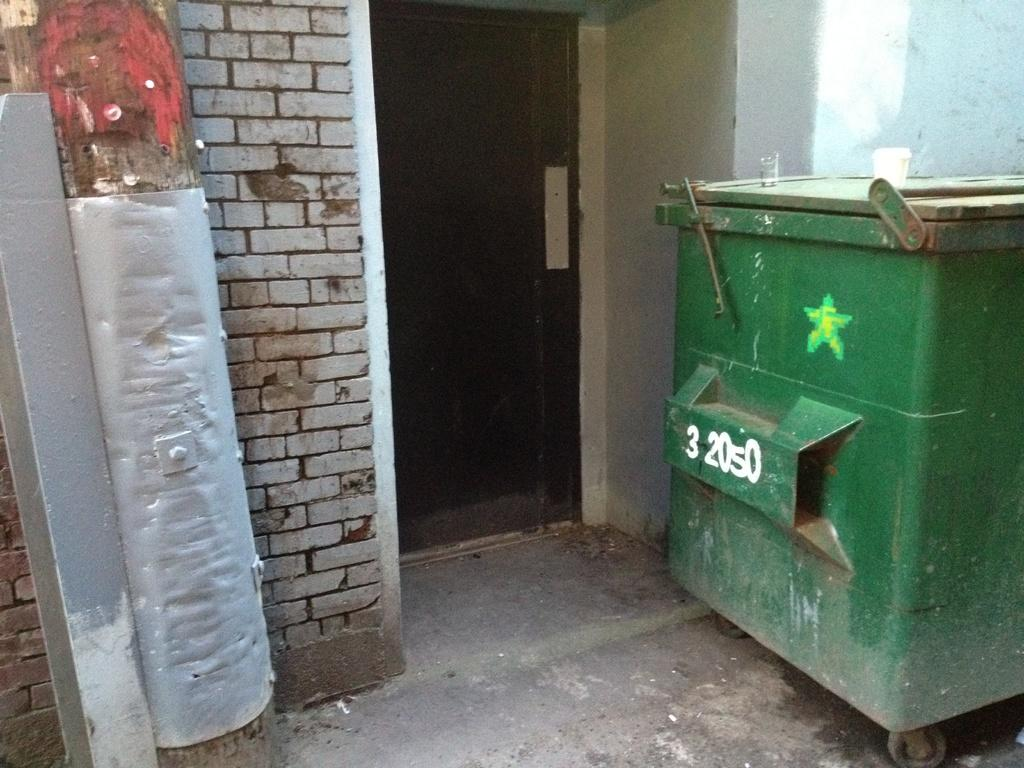<image>
Present a compact description of the photo's key features. Dumpster 32050 has a little star painted on it. 